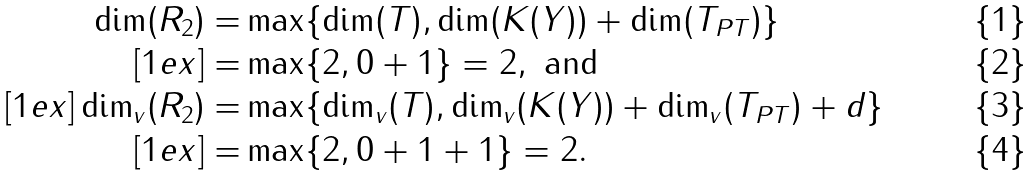<formula> <loc_0><loc_0><loc_500><loc_500>\dim ( R _ { 2 } ) = & \max \{ \dim ( T ) , \dim ( K ( Y ) ) + \dim ( T _ { P T } ) \} \\ [ 1 e x ] = & \max \{ 2 , 0 + 1 \} = 2 , \text { and} \\ [ 1 e x ] \dim _ { v } ( R _ { 2 } ) = & \max \{ \dim _ { v } ( T ) , \dim _ { v } ( K ( Y ) ) + \dim _ { v } ( T _ { P T } ) + d \} \\ [ 1 e x ] = & \max \{ 2 , 0 + 1 + 1 \} = 2 .</formula> 